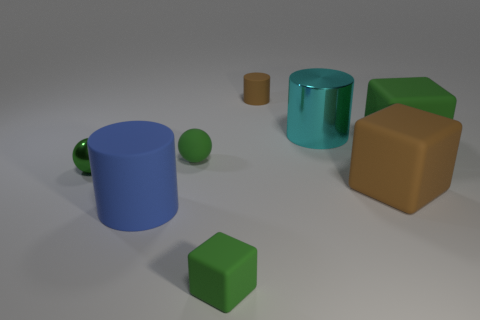There is a big matte object that is the same color as the tiny matte sphere; what shape is it?
Offer a very short reply. Cube. How many objects are big shiny things or small green rubber spheres?
Keep it short and to the point. 2. There is a tiny matte thing that is in front of the big matte object that is to the left of the cyan thing behind the blue rubber thing; what is its color?
Offer a very short reply. Green. Are there any other things that are the same color as the small metallic sphere?
Offer a terse response. Yes. Is the size of the brown block the same as the brown cylinder?
Make the answer very short. No. How many things are either big rubber things that are on the left side of the cyan shiny cylinder or matte objects on the right side of the tiny brown object?
Your answer should be very brief. 3. What material is the green thing on the right side of the cyan shiny cylinder behind the green metallic ball?
Your answer should be compact. Rubber. How many other things are there of the same material as the tiny brown thing?
Give a very brief answer. 5. Is the shape of the green metal thing the same as the big metallic object?
Offer a terse response. No. There is a green matte block on the left side of the large cyan cylinder; what is its size?
Your response must be concise. Small. 